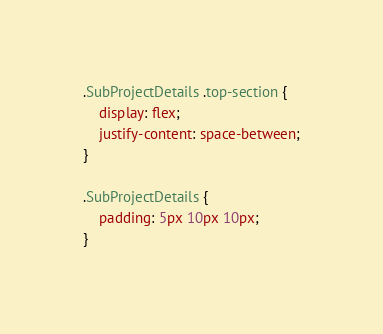Convert code to text. <code><loc_0><loc_0><loc_500><loc_500><_CSS_>
.SubProjectDetails .top-section {
    display: flex;
    justify-content: space-between;
}

.SubProjectDetails {
    padding: 5px 10px 10px;
}

</code> 